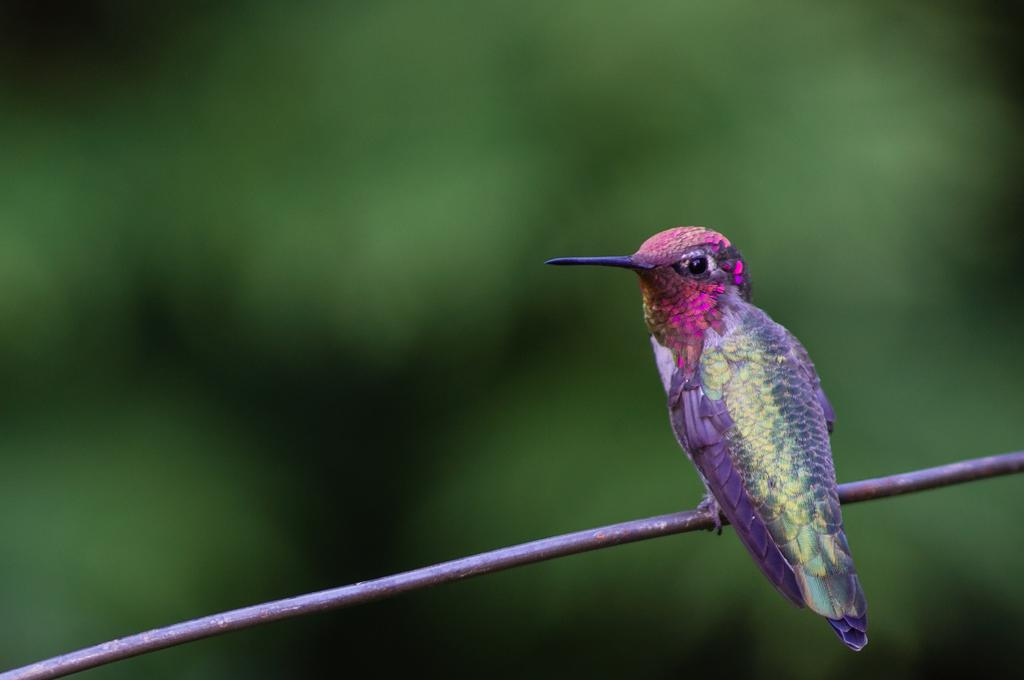What can be observed about the background of the image? The background of the image is blurred. What type of animal is present in the image? There is a bird in the image. On what is the bird perched? The bird is on an object that resembles a wire. What type of queen is sitting next to the bird in the image? There is no queen present in the image; it only features a bird perched on an object that resembles a wire. 